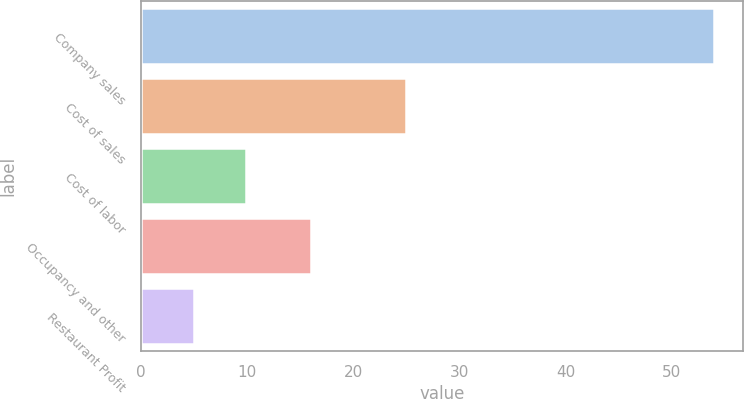Convert chart to OTSL. <chart><loc_0><loc_0><loc_500><loc_500><bar_chart><fcel>Company sales<fcel>Cost of sales<fcel>Cost of labor<fcel>Occupancy and other<fcel>Restaurant Profit<nl><fcel>54<fcel>25<fcel>9.9<fcel>16<fcel>5<nl></chart> 